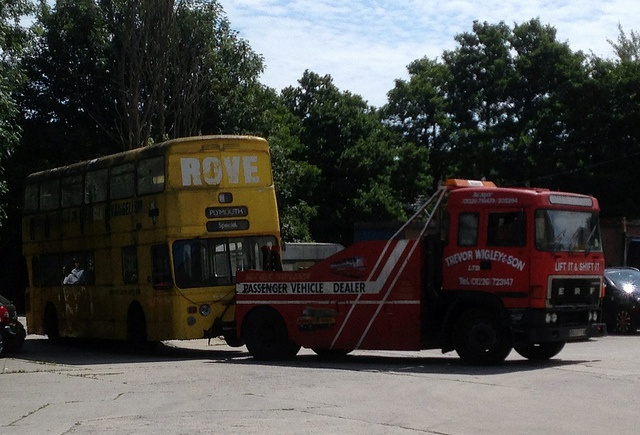Describe the objects in this image and their specific colors. I can see bus in darkgreen, black, olive, and gray tones, truck in darkgreen, black, gray, and maroon tones, car in darkgreen, black, gray, and darkgray tones, people in darkgreen, black, and gray tones, and car in darkgreen, black, maroon, gray, and darkgray tones in this image. 